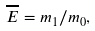Convert formula to latex. <formula><loc_0><loc_0><loc_500><loc_500>\overline { E } = m _ { 1 } / m _ { 0 } ,</formula> 